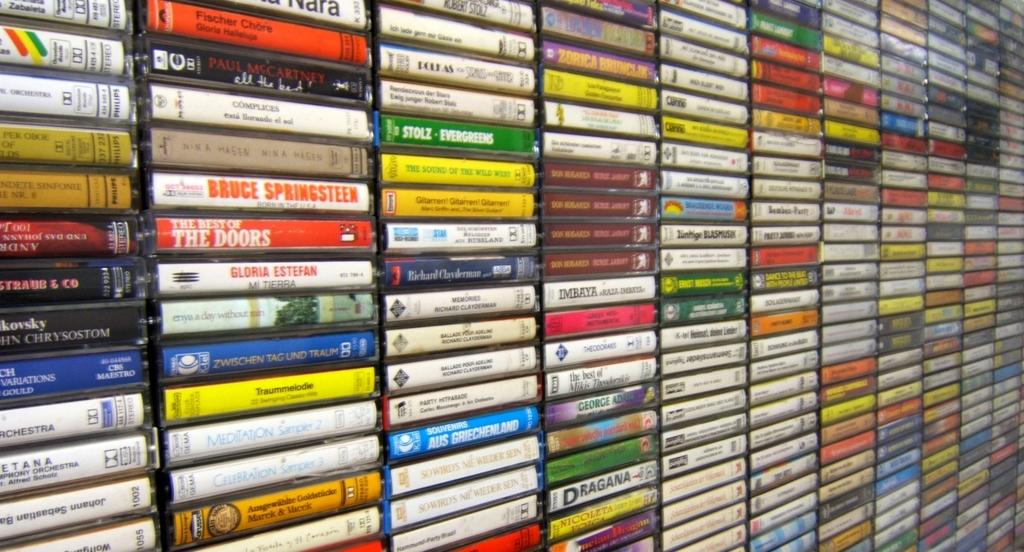Provide a one-sentence caption for the provided image. A couple of the videos feature Bruce Springstein and The Doors. 